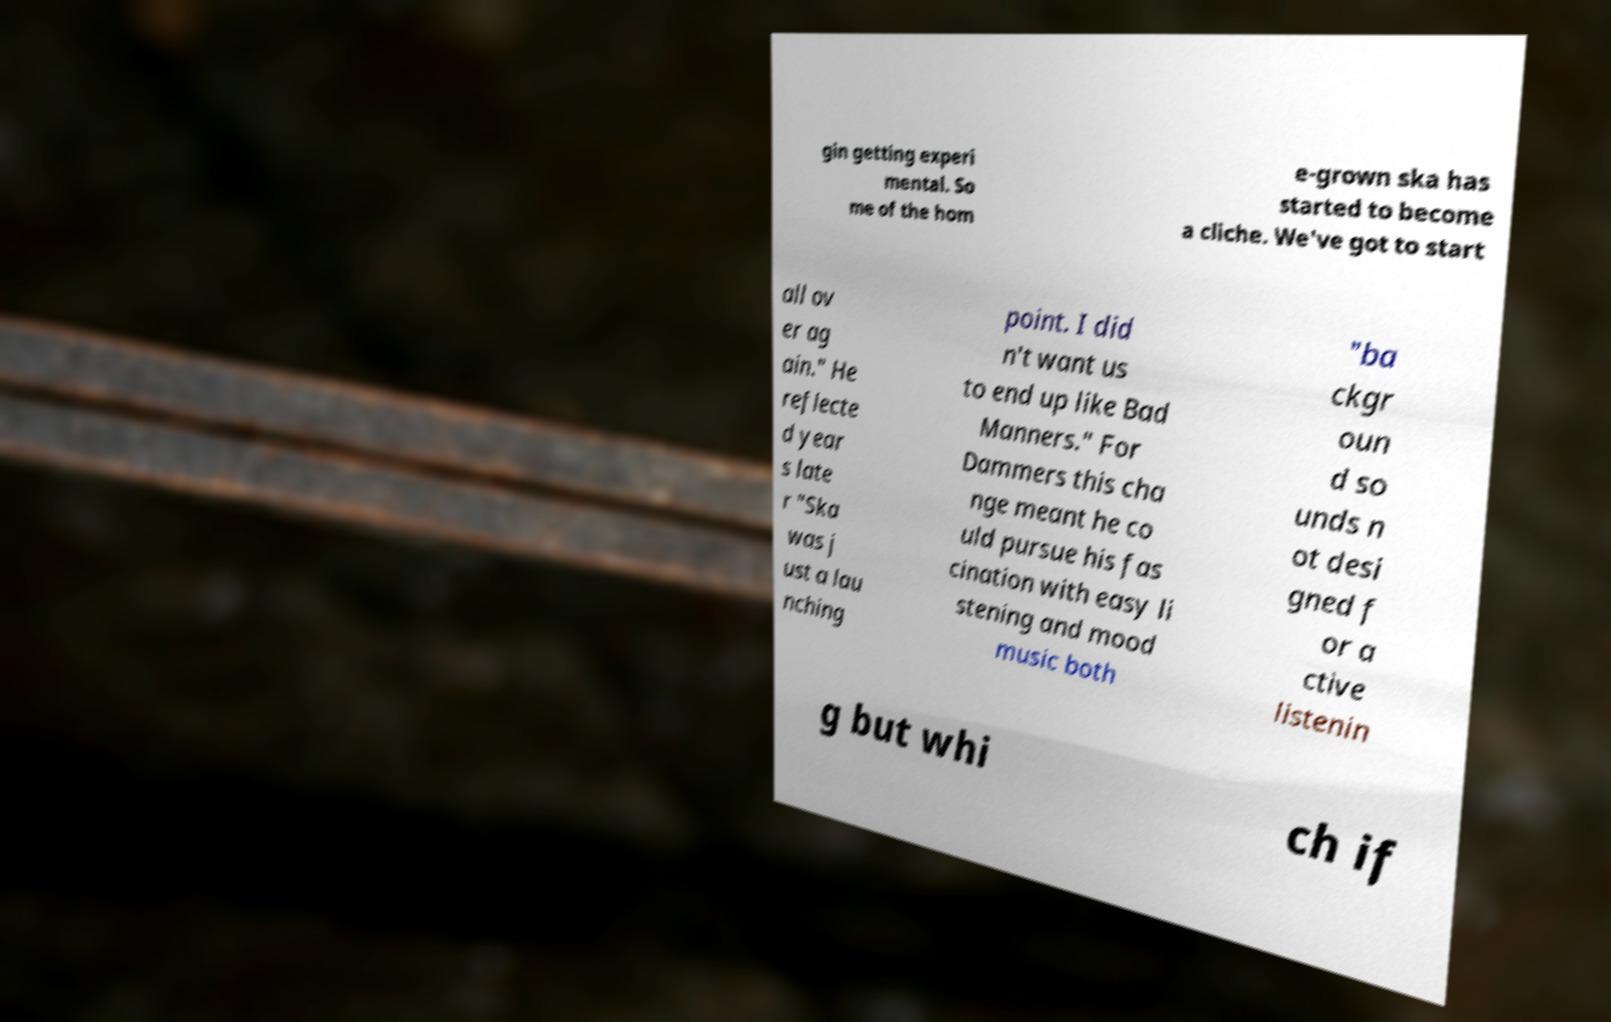For documentation purposes, I need the text within this image transcribed. Could you provide that? gin getting experi mental. So me of the hom e-grown ska has started to become a cliche. We've got to start all ov er ag ain." He reflecte d year s late r "Ska was j ust a lau nching point. I did n't want us to end up like Bad Manners." For Dammers this cha nge meant he co uld pursue his fas cination with easy li stening and mood music both "ba ckgr oun d so unds n ot desi gned f or a ctive listenin g but whi ch if 